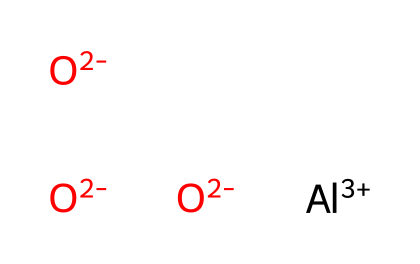How many aluminum atoms are in this composition? The SMILES representation indicates one aluminum atom is present as shown by the symbol 'Al'. Therefore, we count 1 aluminum atom.
Answer: 1 How many oxygen atoms are present? The SMILES shows three instances of 'O' with a negative charge, indicating that there are three oxygen atoms in the structure.
Answer: 3 What is the overall charge of the chemical? The SMILES notation indicates aluminum with a +3 charge and three oxygen atoms each with a -2 charge. Calculating: +3 + (3 * -2) = -3.
Answer: -3 What type of material does aluminum oxide represent? Aluminum oxide is a type of ceramic material used for its hardness and thermal stability.
Answer: ceramic What is the oxidation state of aluminum in this composition? The notation indicates aluminum has a +3 charge, which defines its oxidation state as +3.
Answer: +3 Which properties contribute to its usage in laptop casings? Aluminum oxide's properties such as strength, thermal resistance, and lightweight nature make it suitable for laptop casings.
Answer: strength, thermal resistance, lightweight What bond types are present in the structure? The presence of aluminum and oxygen ions with their charges indicates ionic bonds between aluminum and oxygen in this structure.
Answer: ionic bonds 